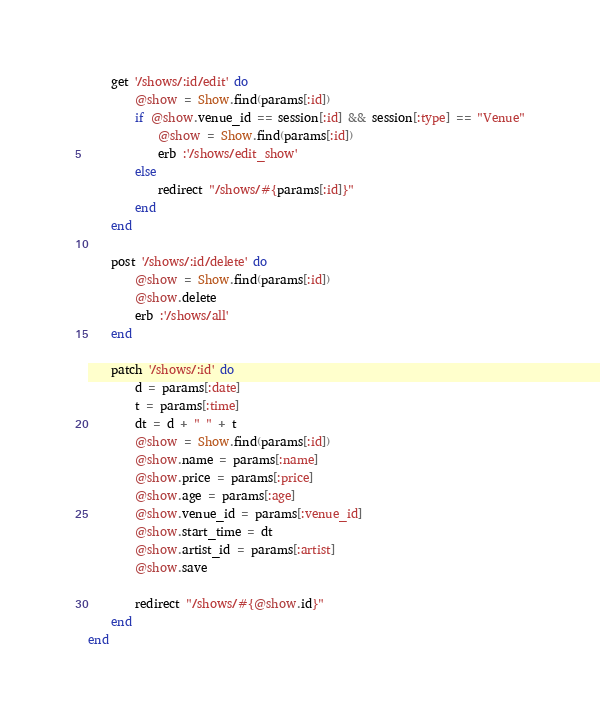<code> <loc_0><loc_0><loc_500><loc_500><_Ruby_>	get '/shows/:id/edit' do 
		@show = Show.find(params[:id])
		if @show.venue_id == session[:id] && session[:type] == "Venue"
			@show = Show.find(params[:id])
			erb :'/shows/edit_show'
		else
			redirect "/shows/#{params[:id]}"
		end
	end

	post '/shows/:id/delete' do 
		@show = Show.find(params[:id])
		@show.delete
		erb :'/shows/all'
	end

	patch '/shows/:id' do
		d = params[:date]
		t = params[:time]
		dt = d + " " + t
		@show = Show.find(params[:id])
		@show.name = params[:name]
		@show.price = params[:price]
		@show.age = params[:age]
		@show.venue_id = params[:venue_id]
		@show.start_time = dt
		@show.artist_id = params[:artist]
		@show.save

		redirect "/shows/#{@show.id}"
	end
end</code> 